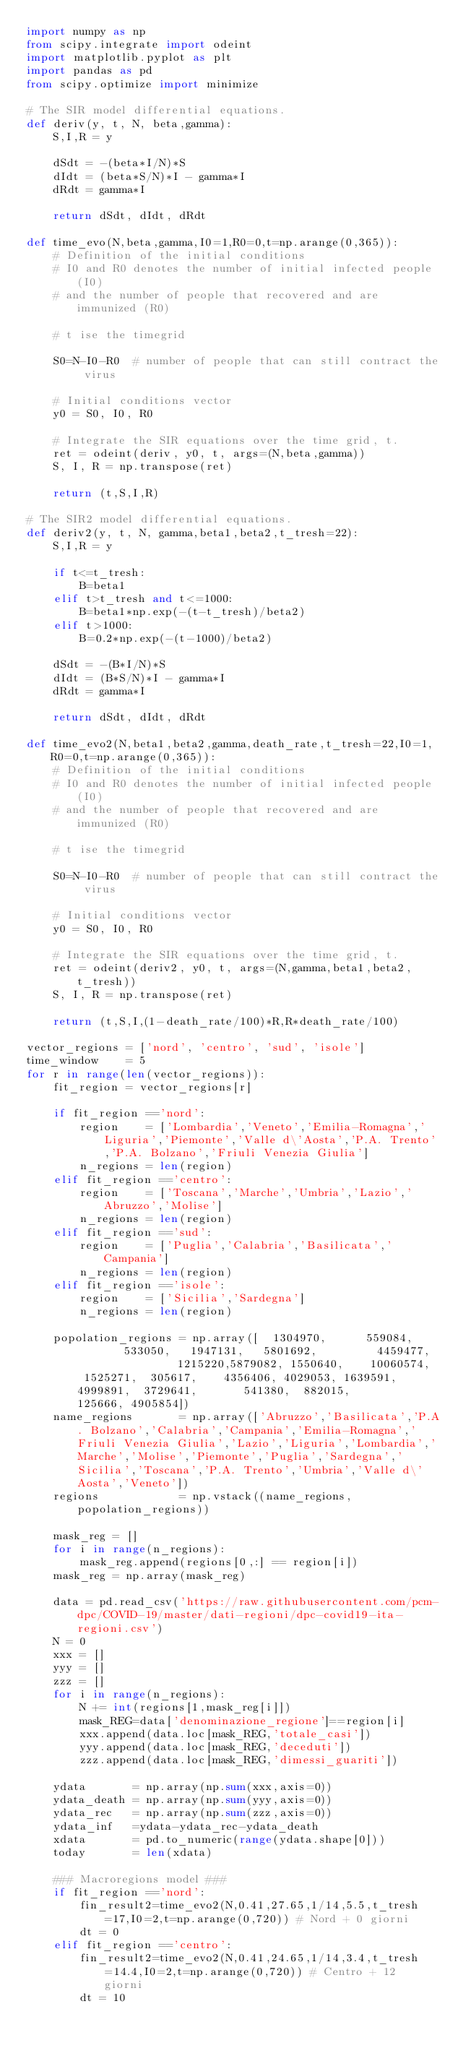<code> <loc_0><loc_0><loc_500><loc_500><_Python_>import numpy as np
from scipy.integrate import odeint
import matplotlib.pyplot as plt
import pandas as pd
from scipy.optimize import minimize

# The SIR model differential equations.
def deriv(y, t, N, beta,gamma):
    S,I,R = y

    dSdt = -(beta*I/N)*S 
    dIdt = (beta*S/N)*I - gamma*I 
    dRdt = gamma*I 
    
    return dSdt, dIdt, dRdt

def time_evo(N,beta,gamma,I0=1,R0=0,t=np.arange(0,365)):
    # Definition of the initial conditions
    # I0 and R0 denotes the number of initial infected people (I0) 
    # and the number of people that recovered and are immunized (R0)
    
    # t ise the timegrid
    
    S0=N-I0-R0  # number of people that can still contract the virus
    
    # Initial conditions vector
    y0 = S0, I0, R0

    # Integrate the SIR equations over the time grid, t.
    ret = odeint(deriv, y0, t, args=(N,beta,gamma))
    S, I, R = np.transpose(ret)
    
    return (t,S,I,R)

# The SIR2 model differential equations.
def deriv2(y, t, N, gamma,beta1,beta2,t_tresh=22):
    S,I,R = y

    if t<=t_tresh:
        B=beta1
    elif t>t_tresh and t<=1000:
        B=beta1*np.exp(-(t-t_tresh)/beta2)
    elif t>1000:
        B=0.2*np.exp(-(t-1000)/beta2)
    
    dSdt = -(B*I/N)*S 
    dIdt = (B*S/N)*I - gamma*I 
    dRdt = gamma*I 
    
    return dSdt, dIdt, dRdt

def time_evo2(N,beta1,beta2,gamma,death_rate,t_tresh=22,I0=1,R0=0,t=np.arange(0,365)):
    # Definition of the initial conditions
    # I0 and R0 denotes the number of initial infected people (I0) 
    # and the number of people that recovered and are immunized (R0)
    
    # t ise the timegrid
    
    S0=N-I0-R0  # number of people that can still contract the virus
    
    # Initial conditions vector
    y0 = S0, I0, R0

    # Integrate the SIR equations over the time grid, t.
    ret = odeint(deriv2, y0, t, args=(N,gamma,beta1,beta2,t_tresh))
    S, I, R = np.transpose(ret)
    
    return (t,S,I,(1-death_rate/100)*R,R*death_rate/100)

vector_regions = ['nord', 'centro', 'sud', 'isole']
time_window    = 5
for r in range(len(vector_regions)):
    fit_region = vector_regions[r]

    if fit_region =='nord':
        region    = ['Lombardia','Veneto','Emilia-Romagna','Liguria','Piemonte','Valle d\'Aosta','P.A. Trento','P.A. Bolzano','Friuli Venezia Giulia'] 
        n_regions = len(region)
    elif fit_region =='centro':
        region    = ['Toscana','Marche','Umbria','Lazio','Abruzzo','Molise']
        n_regions = len(region)
    elif fit_region =='sud':
        region    = ['Puglia','Calabria','Basilicata','Campania']
        n_regions = len(region)
    elif fit_region =='isole':
        region    = ['Sicilia','Sardegna']
        n_regions = len(region)

    popolation_regions = np.array([  1304970,      559084,        533050,   1947131,   5801692,         4459477,                1215220,5879082, 1550640,    10060574,  1525271,  305617,    4356406, 4029053, 1639591,  4999891,  3729641,       541380,  882015,          125666, 4905854])
    name_regions       = np.array(['Abruzzo','Basilicata','P.A. Bolzano','Calabria','Campania','Emilia-Romagna','Friuli Venezia Giulia','Lazio','Liguria','Lombardia','Marche','Molise','Piemonte','Puglia','Sardegna','Sicilia','Toscana','P.A. Trento','Umbria','Valle d\'Aosta','Veneto'])
    regions            = np.vstack((name_regions,popolation_regions))

    mask_reg = []
    for i in range(n_regions):
        mask_reg.append(regions[0,:] == region[i])
    mask_reg = np.array(mask_reg)

    data = pd.read_csv('https://raw.githubusercontent.com/pcm-dpc/COVID-19/master/dati-regioni/dpc-covid19-ita-regioni.csv')
    N = 0
    xxx = []
    yyy = []
    zzz = []
    for i in range(n_regions):
        N += int(regions[1,mask_reg[i]])
        mask_REG=data['denominazione_regione']==region[i]
        xxx.append(data.loc[mask_REG,'totale_casi'])
        yyy.append(data.loc[mask_REG,'deceduti'])
        zzz.append(data.loc[mask_REG,'dimessi_guariti'])

    ydata       = np.array(np.sum(xxx,axis=0))
    ydata_death = np.array(np.sum(yyy,axis=0))
    ydata_rec   = np.array(np.sum(zzz,axis=0))
    ydata_inf   =ydata-ydata_rec-ydata_death
    xdata       = pd.to_numeric(range(ydata.shape[0]))
    today       = len(xdata)
    
    ### Macroregions model ###
    if fit_region =='nord':
        fin_result2=time_evo2(N,0.41,27.65,1/14,5.5,t_tresh=17,I0=2,t=np.arange(0,720)) # Nord + 0 giorni
        dt = 0
    elif fit_region =='centro':
        fin_result2=time_evo2(N,0.41,24.65,1/14,3.4,t_tresh=14.4,I0=2,t=np.arange(0,720)) # Centro + 12 giorni
        dt = 10</code> 